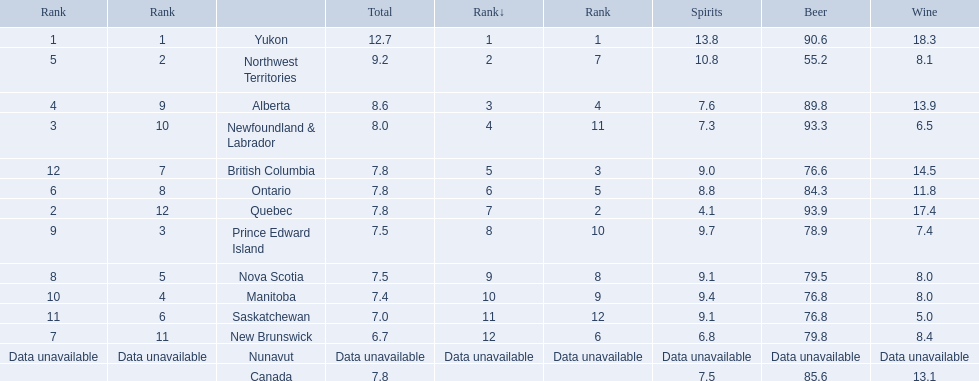What are all the canadian regions? Yukon, Northwest Territories, Alberta, Newfoundland & Labrador, British Columbia, Ontario, Quebec, Prince Edward Island, Nova Scotia, Manitoba, Saskatchewan, New Brunswick, Nunavut, Canada. What was the spirits consumption? 13.8, 10.8, 7.6, 7.3, 9.0, 8.8, 4.1, 9.7, 9.1, 9.4, 9.1, 6.8, Data unavailable, 7.5. What was quebec's spirit consumption? 4.1. 